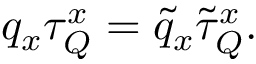<formula> <loc_0><loc_0><loc_500><loc_500>q _ { x } \tau _ { Q } ^ { x } = \tilde { q } _ { x } \tilde { \tau } _ { Q } ^ { x } .</formula> 